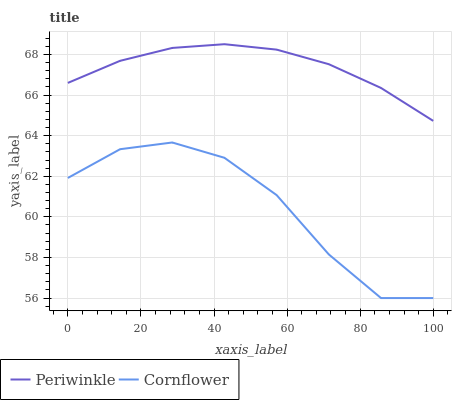Does Cornflower have the minimum area under the curve?
Answer yes or no. Yes. Does Periwinkle have the maximum area under the curve?
Answer yes or no. Yes. Does Periwinkle have the minimum area under the curve?
Answer yes or no. No. Is Periwinkle the smoothest?
Answer yes or no. Yes. Is Cornflower the roughest?
Answer yes or no. Yes. Is Periwinkle the roughest?
Answer yes or no. No. Does Cornflower have the lowest value?
Answer yes or no. Yes. Does Periwinkle have the lowest value?
Answer yes or no. No. Does Periwinkle have the highest value?
Answer yes or no. Yes. Is Cornflower less than Periwinkle?
Answer yes or no. Yes. Is Periwinkle greater than Cornflower?
Answer yes or no. Yes. Does Cornflower intersect Periwinkle?
Answer yes or no. No. 